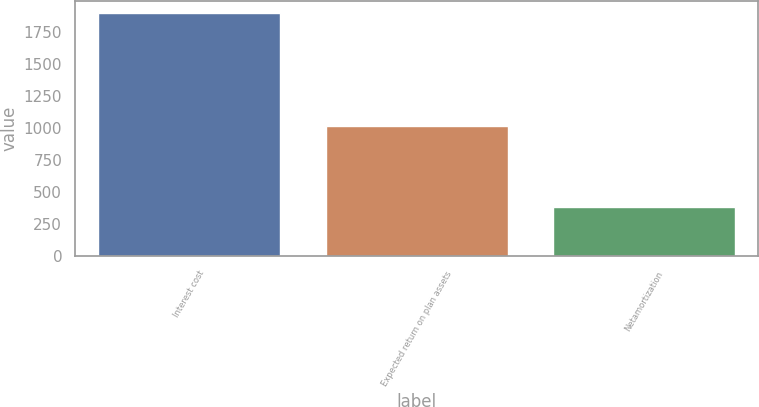Convert chart to OTSL. <chart><loc_0><loc_0><loc_500><loc_500><bar_chart><fcel>Interest cost<fcel>Expected return on plan assets<fcel>Netamortization<nl><fcel>1901<fcel>1017<fcel>381<nl></chart> 